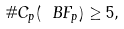<formula> <loc_0><loc_0><loc_500><loc_500>\# { C } _ { p } ( \ B F _ { p } ) \geq 5 ,</formula> 